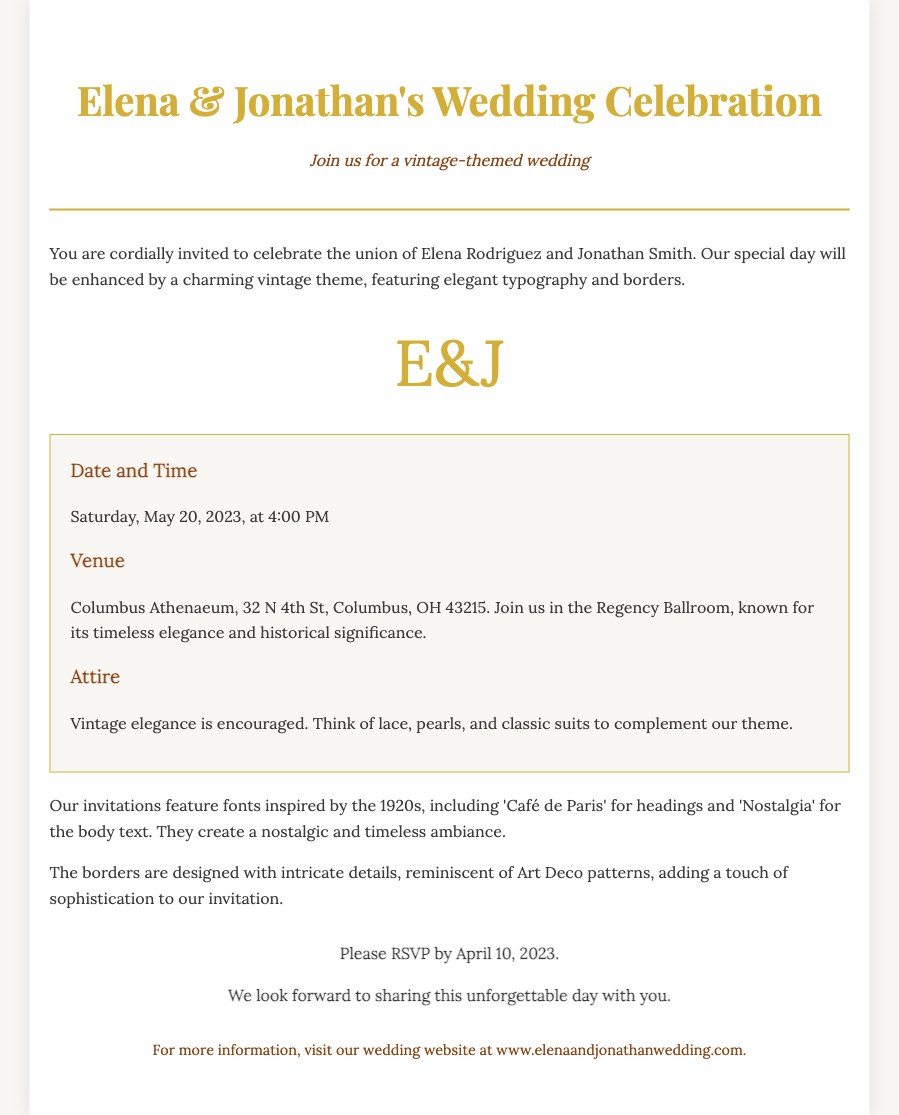What is the date of the wedding? The wedding is scheduled for Saturday, May 20, 2023, at 4:00 PM, as mentioned in the details section.
Answer: May 20, 2023 Where is the wedding venue located? The venue is the Columbus Athenaeum, detailed under the venue section of the invitation.
Answer: Columbus Athenaeum What is the theme of the wedding? The invitation specifies that the wedding will have a vintage theme, which is highlighted at the beginning of the document.
Answer: Vintage-themed What colors are used in the typography? The colors mentioned for the typography include #d4af37 and #8b4513, which are specified in the styling of the text.
Answer: Gold and brown What should guests wear? The attire section suggests that guests should dress in vintage elegance, looking for specific items like lace and pearls.
Answer: Vintage elegance How should guests respond by? The RSVP deadline is explicitly stated in the document, informing guests when they should reply.
Answer: April 10, 2023 What special element is included in the invitation design? The document mentions a classic monogram "E&J," which is a design element featured prominently in the invitation.
Answer: E&J What style of borders are mentioned? The borders are designed with intricate details, reminiscent of Art Deco patterns, as described in the document.
Answer: Art Deco patterns 